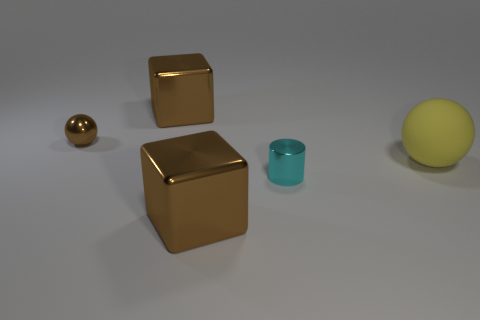There is a block behind the small brown object; is it the same color as the metal sphere?
Ensure brevity in your answer.  Yes. Is there any other thing that is the same color as the shiny sphere?
Offer a very short reply. Yes. How many small brown objects are behind the brown shiny cube in front of the tiny cyan metal cylinder?
Ensure brevity in your answer.  1. What number of things are tiny things in front of the small brown metallic thing or big cubes that are in front of the cyan metallic thing?
Your answer should be very brief. 2. What material is the brown object that is the same shape as the big yellow rubber object?
Provide a succinct answer. Metal. How many things are either cubes that are behind the big rubber thing or rubber cubes?
Ensure brevity in your answer.  1. What shape is the tiny cyan object that is the same material as the small brown object?
Offer a terse response. Cylinder. How many metallic things have the same shape as the matte object?
Offer a terse response. 1. What material is the yellow thing?
Offer a terse response. Rubber. Is the color of the tiny shiny sphere the same as the large cube in front of the small cylinder?
Provide a short and direct response. Yes. 